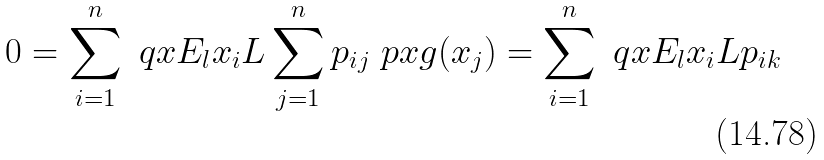Convert formula to latex. <formula><loc_0><loc_0><loc_500><loc_500>0 = \sum _ { i = 1 } ^ { n } \ q x { E _ { l } } { x _ { i } } { L } \sum _ { j = 1 } ^ { n } p _ { i j } \ p x { g ( x _ { j } ) } = \sum _ { i = 1 } ^ { n } \ q x { E _ { l } } { x _ { i } } { L } p _ { i k }</formula> 